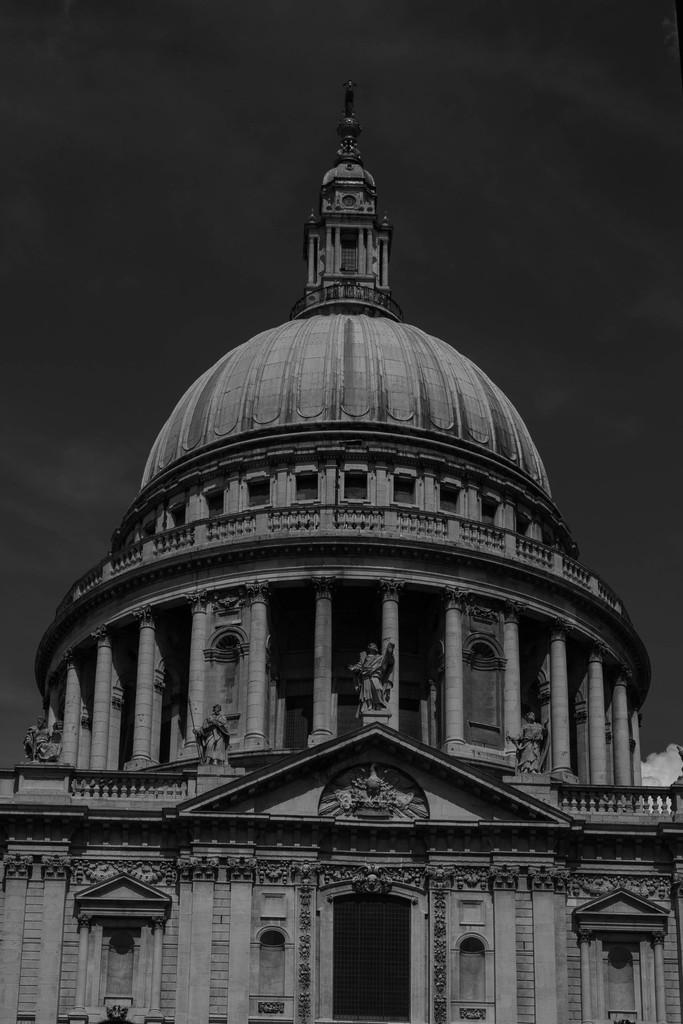What is the color scheme of the image? The image is in black and white. What is the main subject of the image? There is a castle in the center of the image. What architectural features can be seen on the castle? The castle has pillars. Are there any decorative elements on the castle? Yes, the castle has statues. Where is the volleyball court located in the image? There is no volleyball court present in the image; it features a castle with pillars and statues. Can you see any caves near the castle in the image? There are no caves visible in the image; it only shows a castle with pillars and statues. 